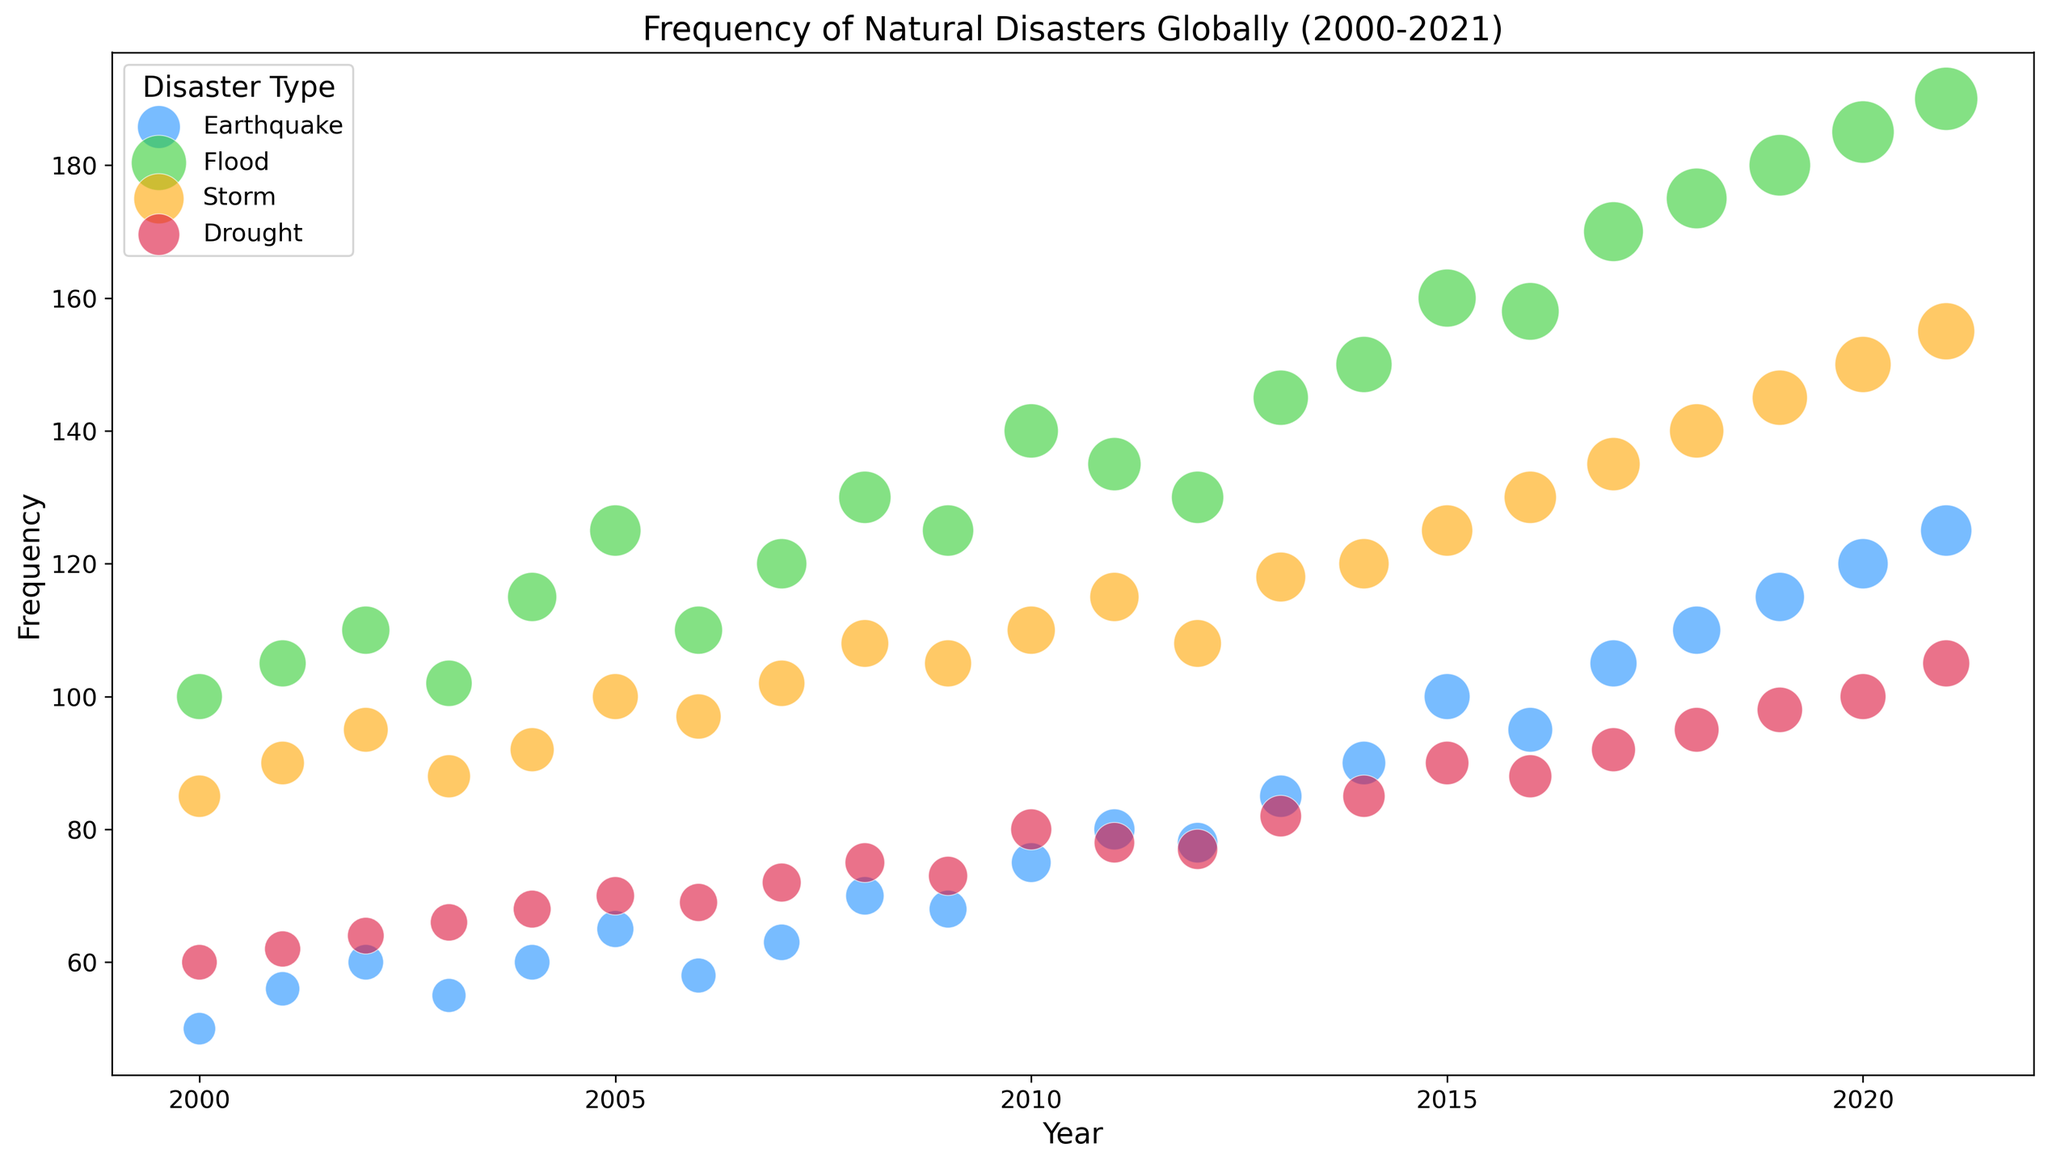Which disaster type showed the most significant increase in frequency from 2000 to 2021? To determine this, observe the change in the bubble size associated with each disaster type from 2000 to 2021. Earthquakes and Floods show significant increases, with Floods moving from 100 in 2000 to 190 in 2021. The increase for Floods is more pronounced.
Answer: Flood Compare the frequency of Earthquakes and Storms in 2015. Which was more frequent? Look at the vertical positions of the Earthquake and Storm bubbles for 2015. The Earthquake bubble corresponds to a frequency of 100, while the Storm bubble corresponds to 125.
Answer: Storm Which disaster type had the least frequency in 2000, and what was that frequency? Locate the smallest bubbles for 2000. The smallest bubble represents Earthquakes, with a frequency of 50.
Answer: Earthquake, 50 How did the frequency of Droughts change from 2010 to 2015? Calculate the difference. To find the difference, subtract the 2010 frequency from the 2015 frequency for Droughts. 90 (2015) - 80 (2010) = 10.
Answer: Increased by 10 What year saw the highest frequency of Storms, and what was the frequency value? Identify the largest bubble associated with Storms and determine its corresponding year. The year is 2021 with a frequency of 155.
Answer: 2021, 155 In which year did Earthquakes surpass a frequency of 100 for the first time? Look for the first occurrence of Earthquake bubbles, which surpass the frequency of 100. In 2017, the frequency reaches 105.
Answer: 2017 Between Floods and Droughts, which showed more consistent growth in frequency from 2000 to 2021? Compare the trends of frequency over the years for both Floods and Droughts. Floods show a more consistent increase compared to Droughts, which have a variable trend.
Answer: Floods Comparing all disaster types in 2010, which one had the lowest frequency and what was the value? Check the smallest bubble for 2010. Drought had the lowest frequency with a value of 80.
Answer: Drought, 80 If you sum up the frequencies of Earthquakes and Floods for the year 2008, what total do you get? Add the frequencies of Earthquakes and Floods for 2008. 70 (Earthquake) + 130 (Flood) = 200.
Answer: 200 